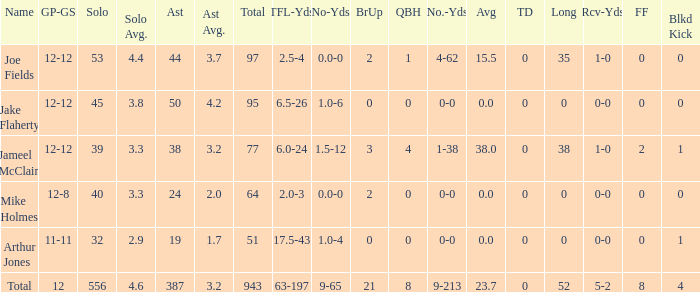How many players named jake flaherty? 1.0. 